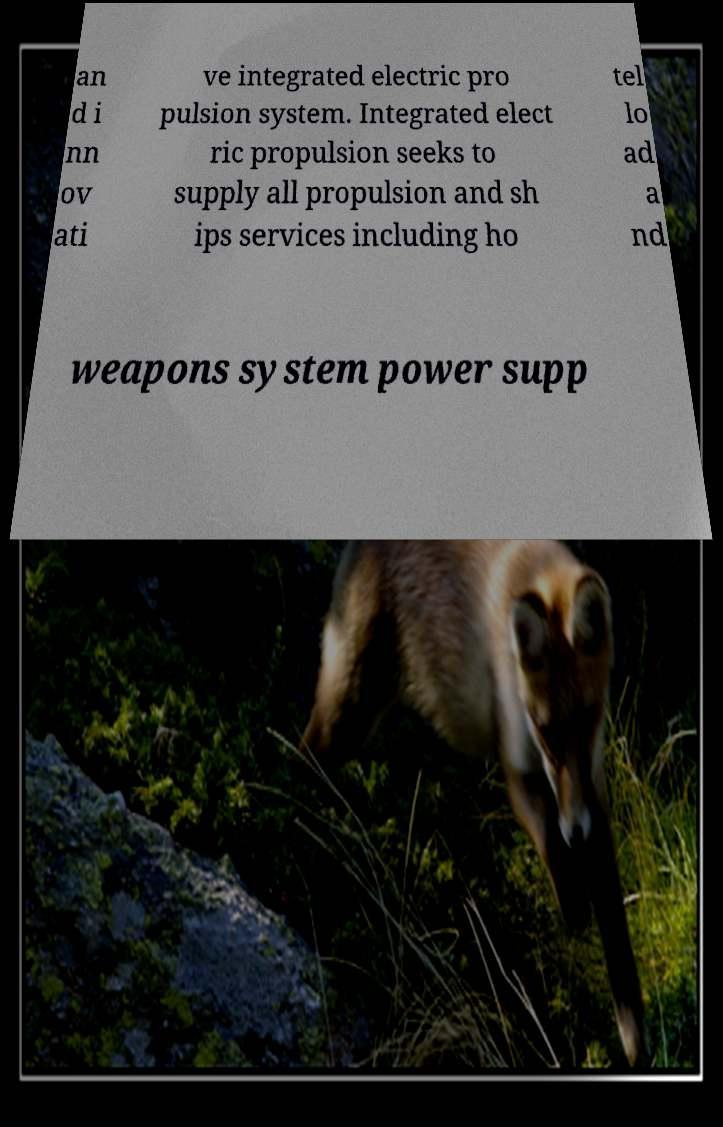Could you assist in decoding the text presented in this image and type it out clearly? an d i nn ov ati ve integrated electric pro pulsion system. Integrated elect ric propulsion seeks to supply all propulsion and sh ips services including ho tel lo ad a nd weapons system power supp 